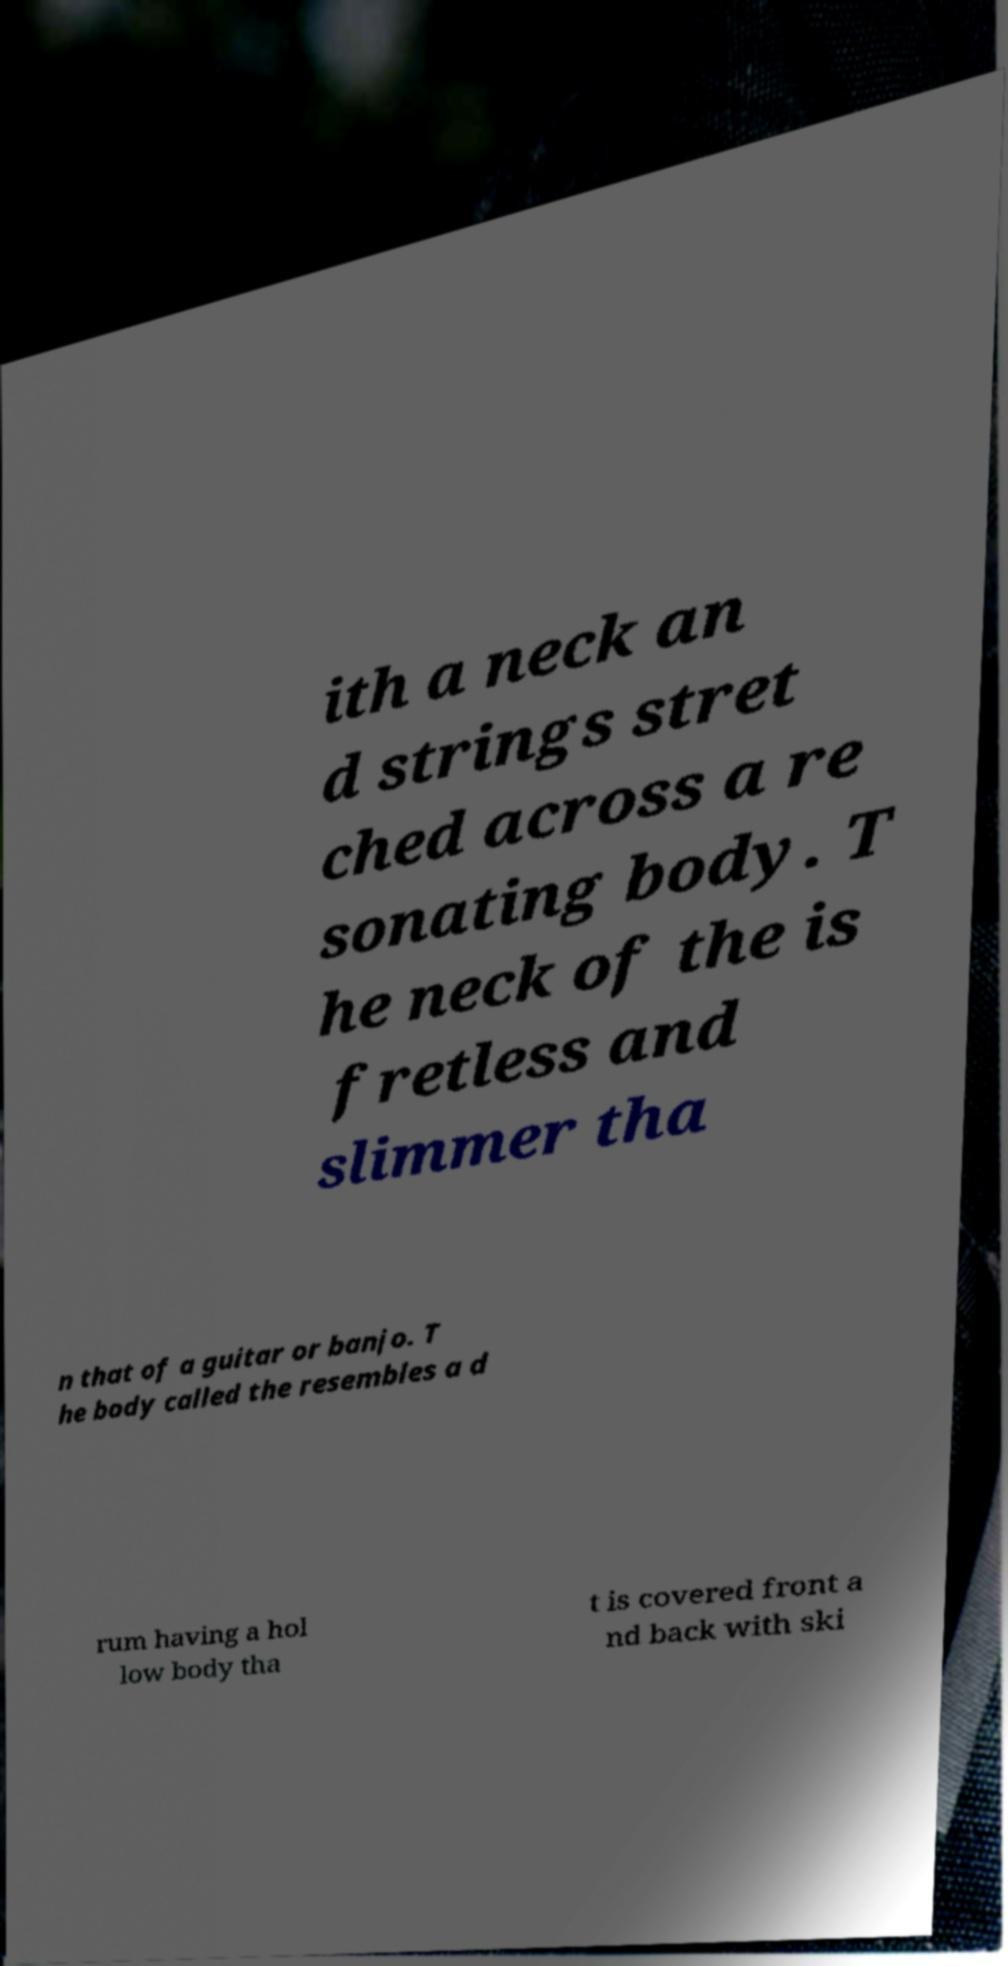Please read and relay the text visible in this image. What does it say? ith a neck an d strings stret ched across a re sonating body. T he neck of the is fretless and slimmer tha n that of a guitar or banjo. T he body called the resembles a d rum having a hol low body tha t is covered front a nd back with ski 